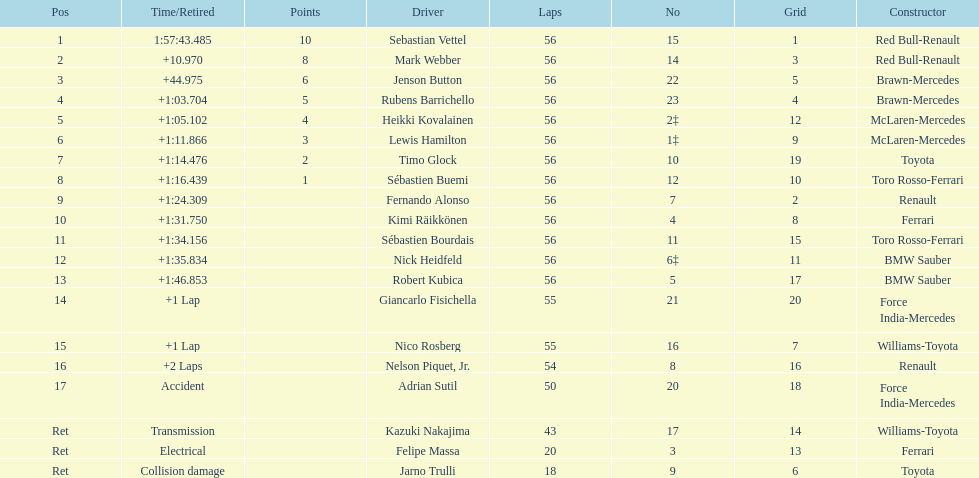What was jenson button's time? +44.975. 